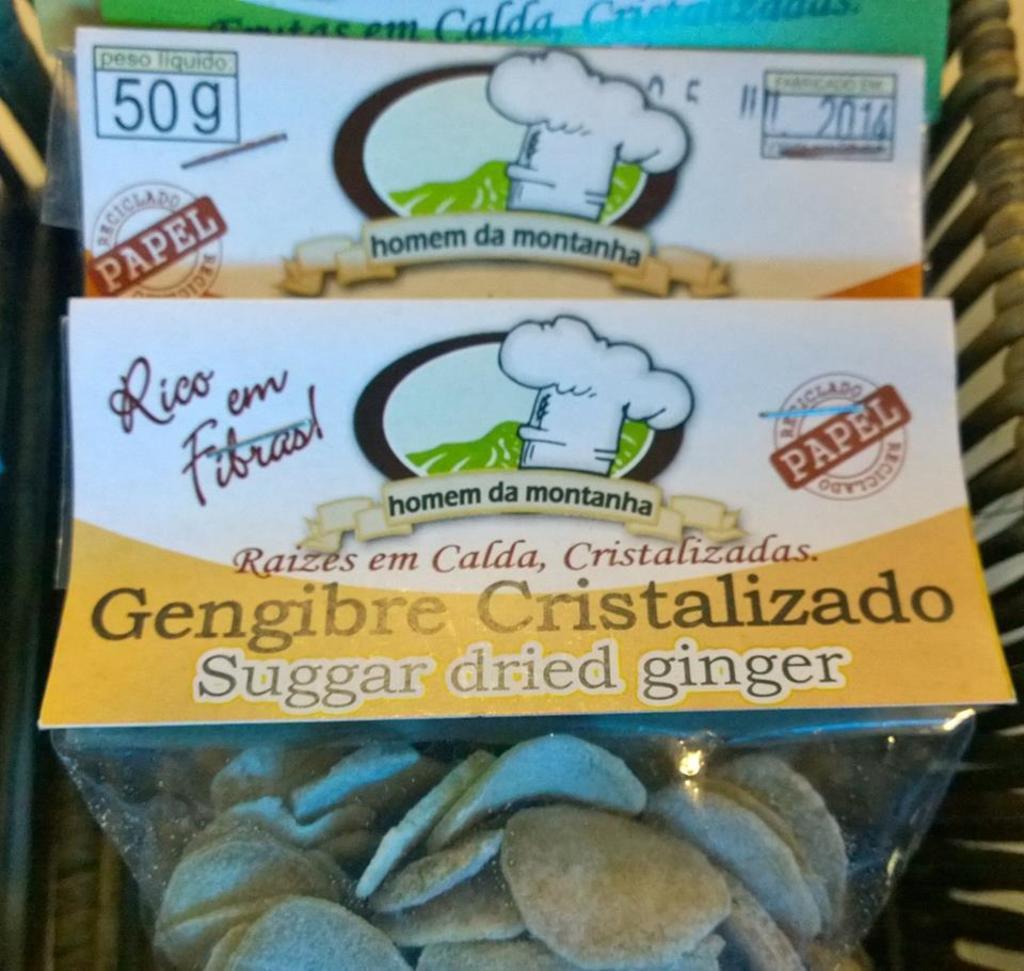Could you give a brief overview of what you see in this image? In this image there are few items placed, on which there are label with some images and text on it. 